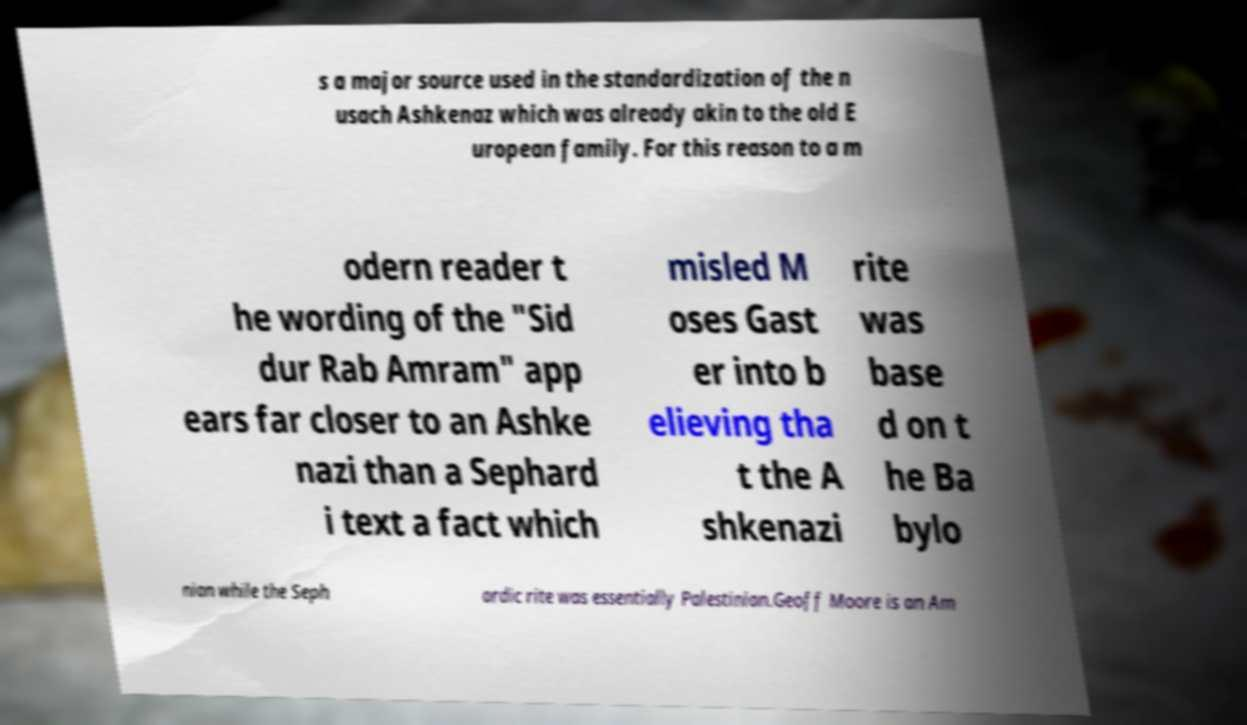Please identify and transcribe the text found in this image. s a major source used in the standardization of the n usach Ashkenaz which was already akin to the old E uropean family. For this reason to a m odern reader t he wording of the "Sid dur Rab Amram" app ears far closer to an Ashke nazi than a Sephard i text a fact which misled M oses Gast er into b elieving tha t the A shkenazi rite was base d on t he Ba bylo nian while the Seph ardic rite was essentially Palestinian.Geoff Moore is an Am 